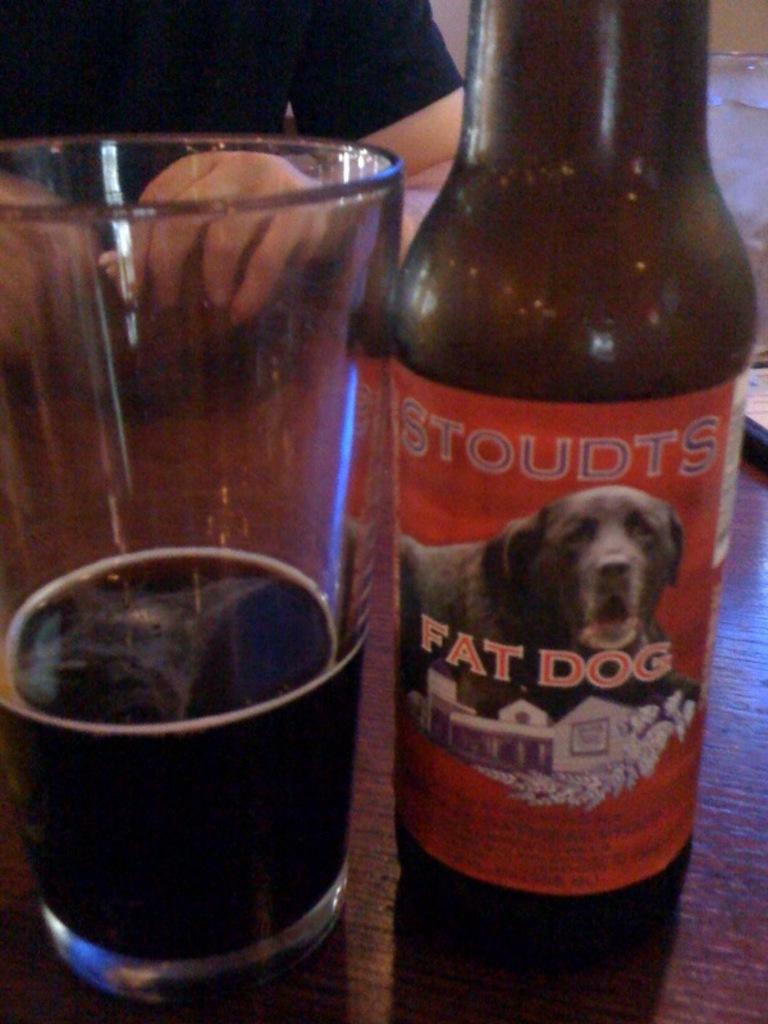What style of beer is this?
Make the answer very short. Fat dog. 